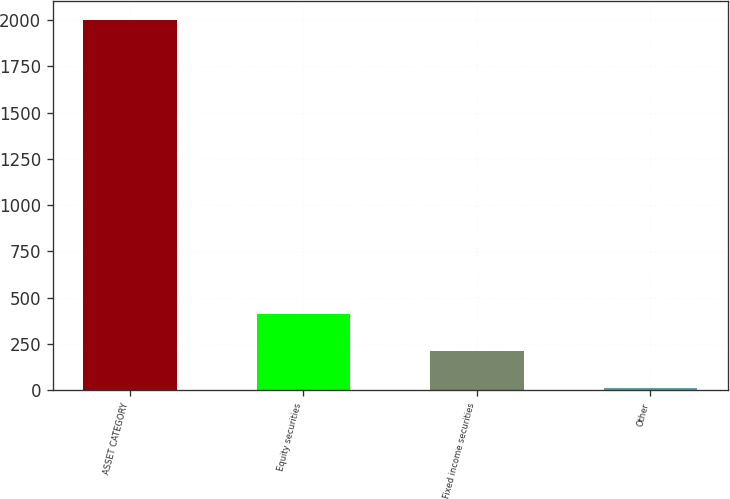<chart> <loc_0><loc_0><loc_500><loc_500><bar_chart><fcel>ASSET CATEGORY<fcel>Equity securities<fcel>Fixed income securities<fcel>Other<nl><fcel>2002<fcel>408.4<fcel>209.2<fcel>10<nl></chart> 